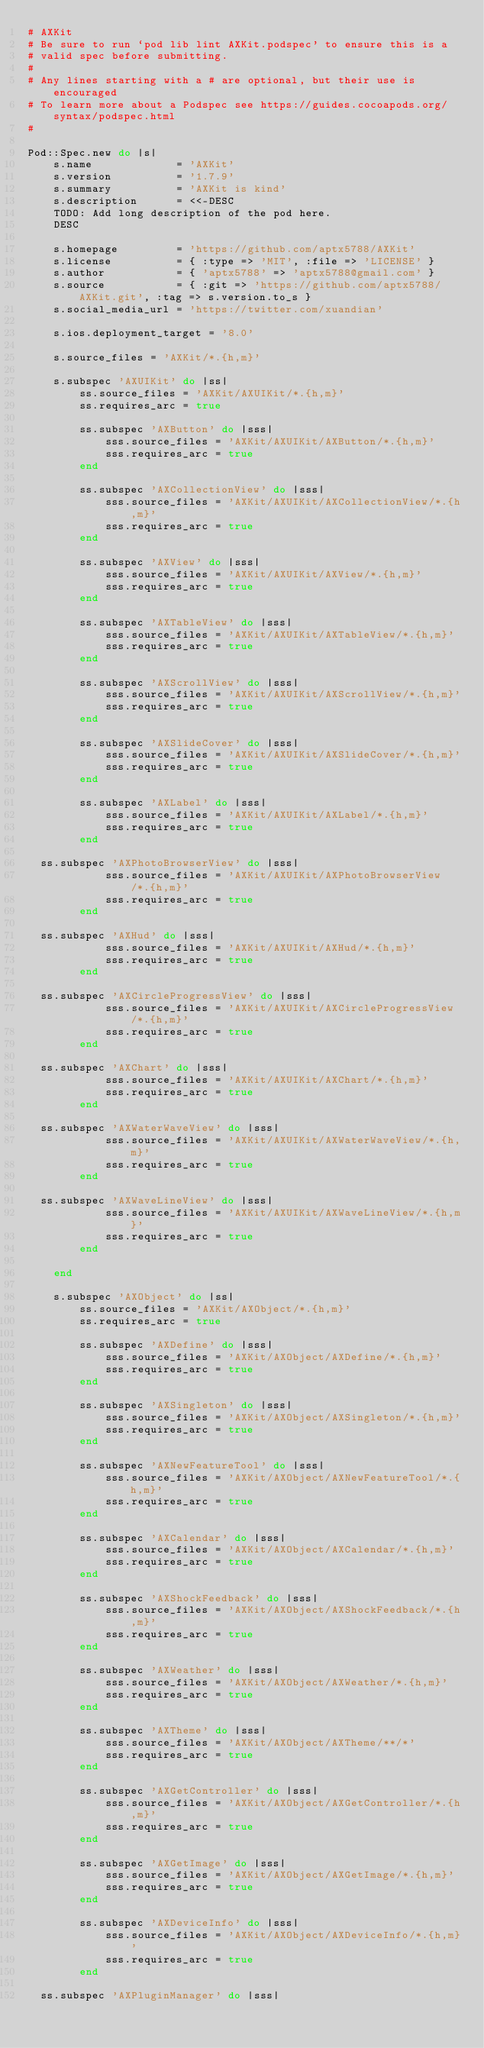Convert code to text. <code><loc_0><loc_0><loc_500><loc_500><_Ruby_># AXKit
# Be sure to run `pod lib lint AXKit.podspec' to ensure this is a
# valid spec before submitting.
#
# Any lines starting with a # are optional, but their use is encouraged
# To learn more about a Podspec see https://guides.cocoapods.org/syntax/podspec.html
#

Pod::Spec.new do |s|
    s.name             = 'AXKit'
    s.version          = '1.7.9'
    s.summary          = 'AXKit is kind'
    s.description      = <<-DESC
    TODO: Add long description of the pod here.
    DESC
    
    s.homepage         = 'https://github.com/aptx5788/AXKit'
    s.license          = { :type => 'MIT', :file => 'LICENSE' }
    s.author           = { 'aptx5788' => 'aptx5788@gmail.com' }
    s.source           = { :git => 'https://github.com/aptx5788/AXKit.git', :tag => s.version.to_s }
    s.social_media_url = 'https://twitter.com/xuandian'
    
    s.ios.deployment_target = '8.0'
    
    s.source_files = 'AXKit/*.{h,m}'
    
    s.subspec 'AXUIKit' do |ss|
        ss.source_files = 'AXKit/AXUIKit/*.{h,m}'
        ss.requires_arc = true
        
        ss.subspec 'AXButton' do |sss|
            sss.source_files = 'AXKit/AXUIKit/AXButton/*.{h,m}'
            sss.requires_arc = true
        end
        
        ss.subspec 'AXCollectionView' do |sss|
            sss.source_files = 'AXKit/AXUIKit/AXCollectionView/*.{h,m}'
            sss.requires_arc = true
        end
        
        ss.subspec 'AXView' do |sss|
            sss.source_files = 'AXKit/AXUIKit/AXView/*.{h,m}'
            sss.requires_arc = true
        end
        
        ss.subspec 'AXTableView' do |sss|
            sss.source_files = 'AXKit/AXUIKit/AXTableView/*.{h,m}'
            sss.requires_arc = true
        end
        
        ss.subspec 'AXScrollView' do |sss|
            sss.source_files = 'AXKit/AXUIKit/AXScrollView/*.{h,m}'
            sss.requires_arc = true
        end
        
        ss.subspec 'AXSlideCover' do |sss|
            sss.source_files = 'AXKit/AXUIKit/AXSlideCover/*.{h,m}'
            sss.requires_arc = true
        end
       
        ss.subspec 'AXLabel' do |sss|
            sss.source_files = 'AXKit/AXUIKit/AXLabel/*.{h,m}'
            sss.requires_arc = true
        end
	
	ss.subspec 'AXPhotoBrowserView' do |sss|
            sss.source_files = 'AXKit/AXUIKit/AXPhotoBrowserView/*.{h,m}'
            sss.requires_arc = true
        end

	ss.subspec 'AXHud' do |sss|
            sss.source_files = 'AXKit/AXUIKit/AXHud/*.{h,m}'
            sss.requires_arc = true
        end
	
	ss.subspec 'AXCircleProgressView' do |sss|
            sss.source_files = 'AXKit/AXUIKit/AXCircleProgressView/*.{h,m}'
            sss.requires_arc = true
        end
	
	ss.subspec 'AXChart' do |sss|
            sss.source_files = 'AXKit/AXUIKit/AXChart/*.{h,m}'
            sss.requires_arc = true
        end
	
	ss.subspec 'AXWaterWaveView' do |sss|
            sss.source_files = 'AXKit/AXUIKit/AXWaterWaveView/*.{h,m}'
            sss.requires_arc = true
        end

	ss.subspec 'AXWaveLineView' do |sss|
            sss.source_files = 'AXKit/AXUIKit/AXWaveLineView/*.{h,m}'
            sss.requires_arc = true
        end
        
    end
    
    s.subspec 'AXObject' do |ss|
        ss.source_files = 'AXKit/AXObject/*.{h,m}'
        ss.requires_arc = true
        
        ss.subspec 'AXDefine' do |sss|
            sss.source_files = 'AXKit/AXObject/AXDefine/*.{h,m}'
            sss.requires_arc = true
        end
        
        ss.subspec 'AXSingleton' do |sss|
            sss.source_files = 'AXKit/AXObject/AXSingleton/*.{h,m}'
            sss.requires_arc = true
        end
        
        ss.subspec 'AXNewFeatureTool' do |sss|
            sss.source_files = 'AXKit/AXObject/AXNewFeatureTool/*.{h,m}'
            sss.requires_arc = true
        end
        
        ss.subspec 'AXCalendar' do |sss|
            sss.source_files = 'AXKit/AXObject/AXCalendar/*.{h,m}'
            sss.requires_arc = true
        end
        
        ss.subspec 'AXShockFeedback' do |sss|
            sss.source_files = 'AXKit/AXObject/AXShockFeedback/*.{h,m}'
            sss.requires_arc = true
        end
        
        ss.subspec 'AXWeather' do |sss|
            sss.source_files = 'AXKit/AXObject/AXWeather/*.{h,m}'
            sss.requires_arc = true
        end
        
        ss.subspec 'AXTheme' do |sss|
            sss.source_files = 'AXKit/AXObject/AXTheme/**/*'
            sss.requires_arc = true
        end

        ss.subspec 'AXGetController' do |sss|
            sss.source_files = 'AXKit/AXObject/AXGetController/*.{h,m}'
            sss.requires_arc = true
        end

        ss.subspec 'AXGetImage' do |sss|
            sss.source_files = 'AXKit/AXObject/AXGetImage/*.{h,m}'
            sss.requires_arc = true
        end

        ss.subspec 'AXDeviceInfo' do |sss|
            sss.source_files = 'AXKit/AXObject/AXDeviceInfo/*.{h,m}'
            sss.requires_arc = true
        end

 	ss.subspec 'AXPluginManager' do |sss|</code> 